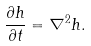Convert formula to latex. <formula><loc_0><loc_0><loc_500><loc_500>\frac { \partial h } { \partial t } = \nabla ^ { 2 } h .</formula> 